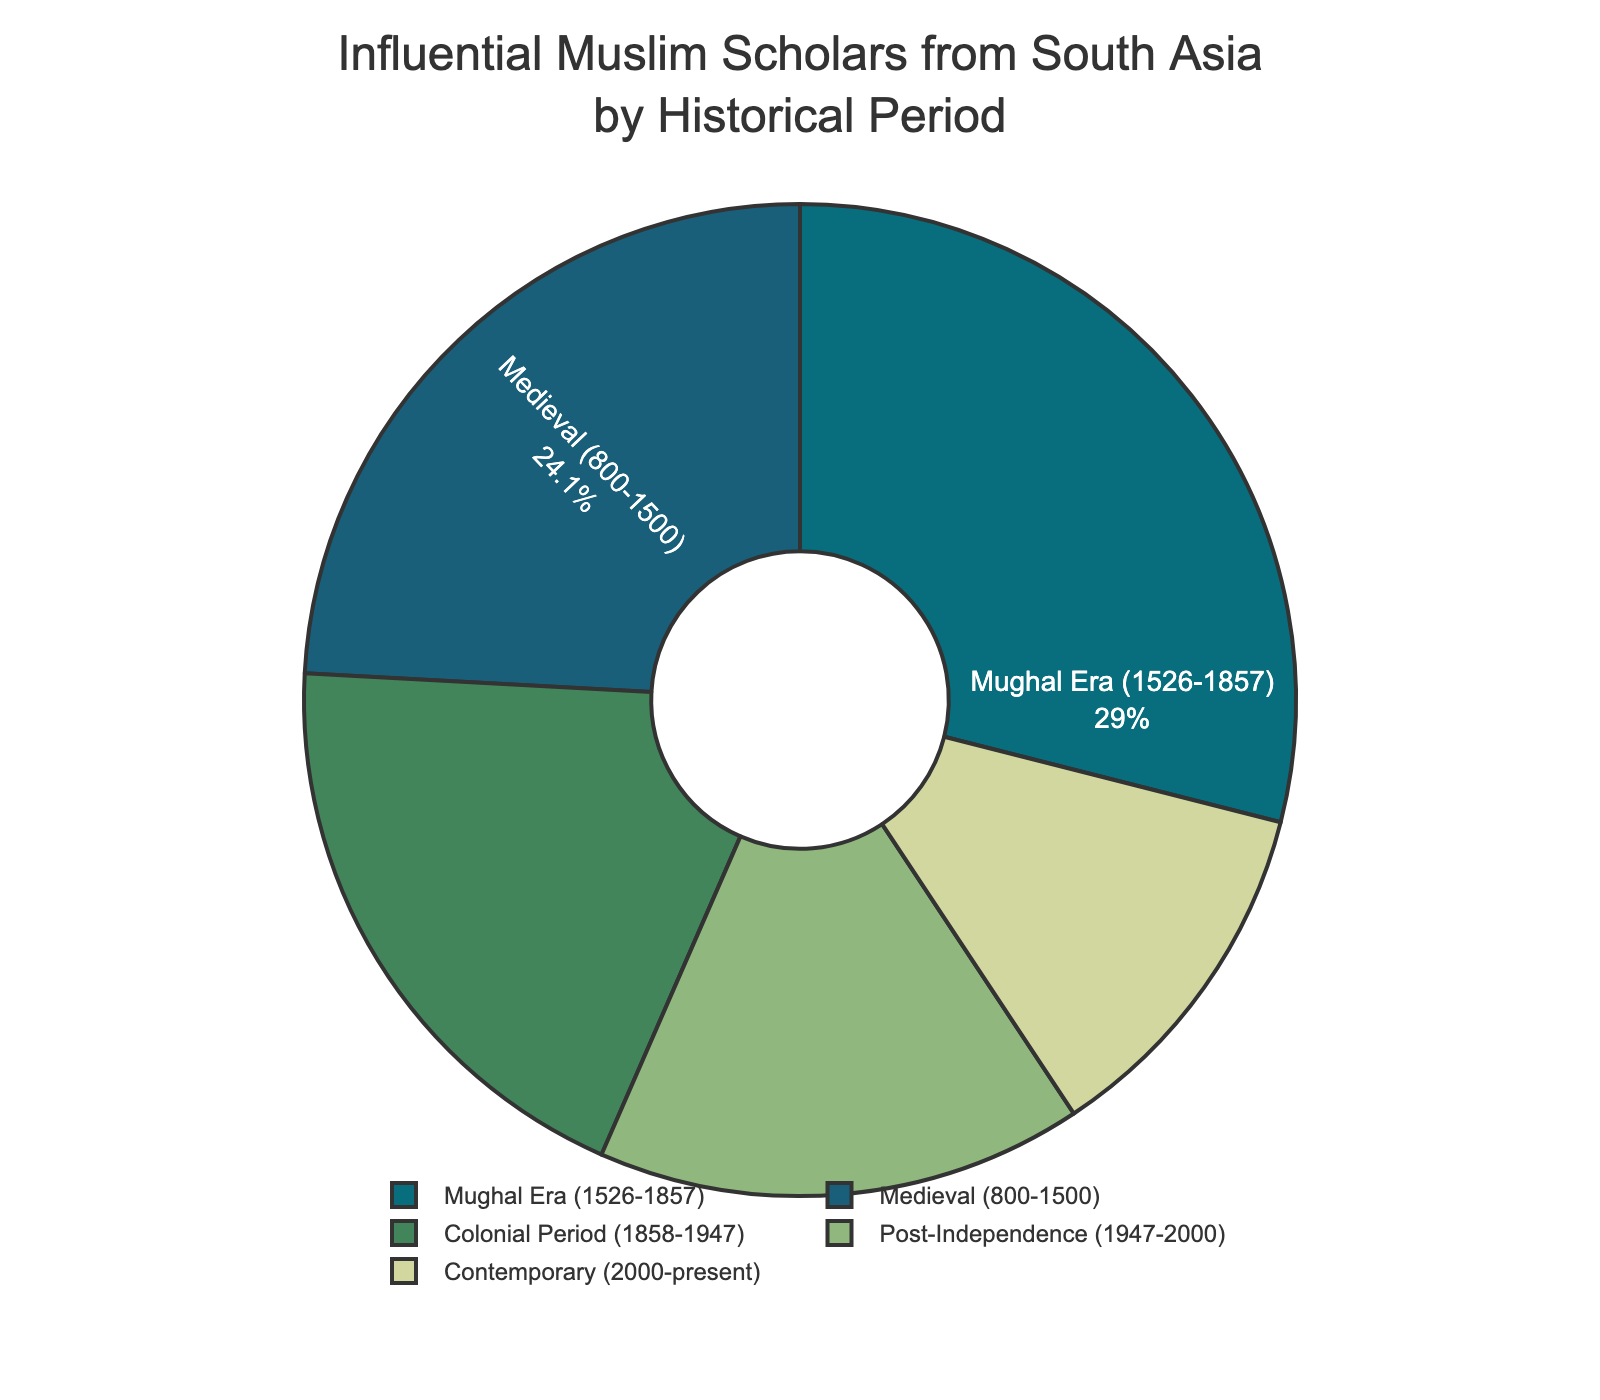What historical period has the highest number of influential scholars? The pie chart shows the number of influential scholars from South Asia by different historical periods. By visually inspecting the chart, we can see that the Mughal Era (1526-1857) has the largest segment.
Answer: Mughal Era (1526-1857) What percentage of influential scholars came from the Medieval period? The pie chart includes both the number and percentage of influential scholars for each period. Looking at the Medieval period's segment, it's labeled with its percentage.
Answer: 27% Which two historical periods combined account for more than half of the influential scholars? By examining the pie chart, adding the percentages of the largest slices, we see that the Mughal Era (32%) and the Medieval period (27%) together account for 59%.
Answer: Mughal Era and Medieval period How does the number of influential scholars in the Colonial Period compare to the Contemporary period? By comparing the sizes of the slices and their labeled values, we can determine that the Colonial Period has 28 scholars, which is more than the 17 scholars in the Contemporary period.
Answer: Colonial Period has more What's the difference in the number of influential scholars between the Post-Independence and Contemporary periods? Looking at the values provided on the chart for both periods, the Post-Independence period has 23 scholars while the Contemporary period has 17. The difference is 23 - 17.
Answer: 6 Which historical period has the smallest number of influential scholars? The smallest segment on the pie chart visually indicates the period with the least scholars. The Contemporary period (2000-present) has the smallest segment.
Answer: Contemporary (2000-present) What fraction of the total influential scholars come from the Post-Independence period? By checking the chart, the Post-Independence period has 23 scholars. Adding up all the provided values gives a total of: 35 + 42 + 28 + 23 + 17 = 145. The fraction is 23 / 145.
Answer: 23/145 If you combine the number of scholars from the Colonial Period and the Contemporary period, what percentage of the total does that represent? First, add the numbers from the Colonial Period and Contemporary period: 28 + 17 = 45. Then, the total number of scholars is 145. The percentage is (45 / 145) * 100.
Answer: 31% Between the Mughal Era and Post-Independence periods, which has a smaller visual slice? By visual inspection of the pie chart, the Post-Independence period's slice is smaller than the Mughal Era's slice.
Answer: Post-Independence period How much larger is the Mughal Era segment compared to the Contemporary period? The Mughal Era has 42 scholars and the Contemporary period has 17. The difference is 42 - 17.
Answer: 25 